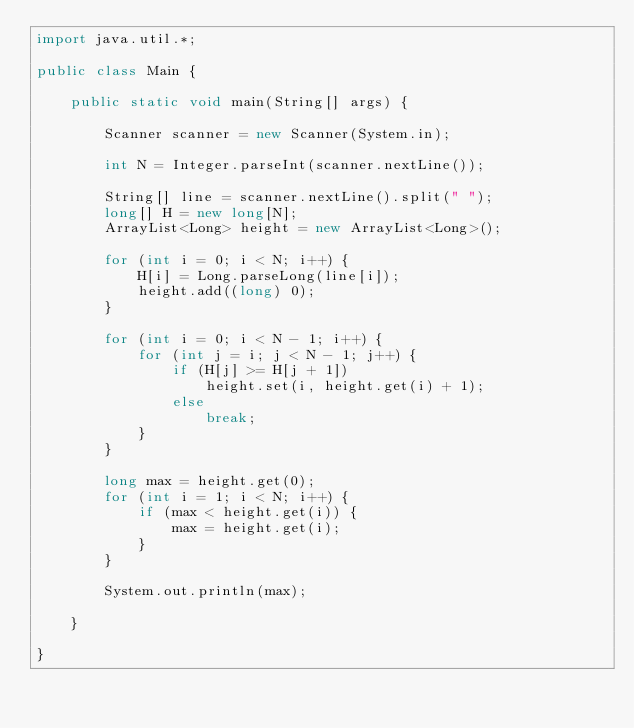<code> <loc_0><loc_0><loc_500><loc_500><_Java_>import java.util.*;

public class Main {

	public static void main(String[] args) {

		Scanner scanner = new Scanner(System.in);

		int N = Integer.parseInt(scanner.nextLine());

		String[] line = scanner.nextLine().split(" ");
		long[] H = new long[N];
		ArrayList<Long> height = new ArrayList<Long>();

		for (int i = 0; i < N; i++) {
			H[i] = Long.parseLong(line[i]);
			height.add((long) 0);
		}

		for (int i = 0; i < N - 1; i++) {
			for (int j = i; j < N - 1; j++) {
				if (H[j] >= H[j + 1])
					height.set(i, height.get(i) + 1);
				else
					break;
			}
		}

		long max = height.get(0);
		for (int i = 1; i < N; i++) {
			if (max < height.get(i)) {
				max = height.get(i);
			}
		}

		System.out.println(max);

	}

}
</code> 